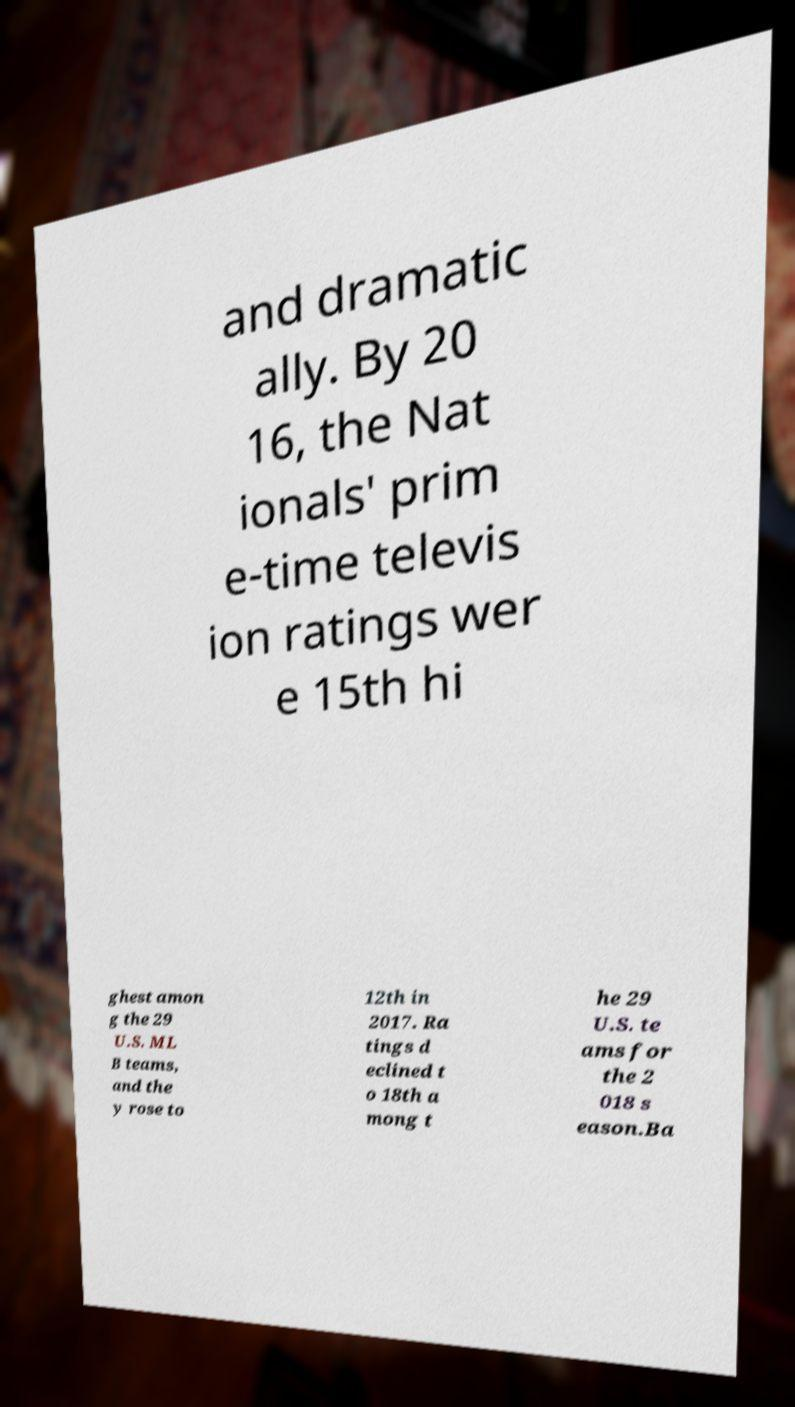Can you read and provide the text displayed in the image?This photo seems to have some interesting text. Can you extract and type it out for me? and dramatic ally. By 20 16, the Nat ionals′ prim e-time televis ion ratings wer e 15th hi ghest amon g the 29 U.S. ML B teams, and the y rose to 12th in 2017. Ra tings d eclined t o 18th a mong t he 29 U.S. te ams for the 2 018 s eason.Ba 